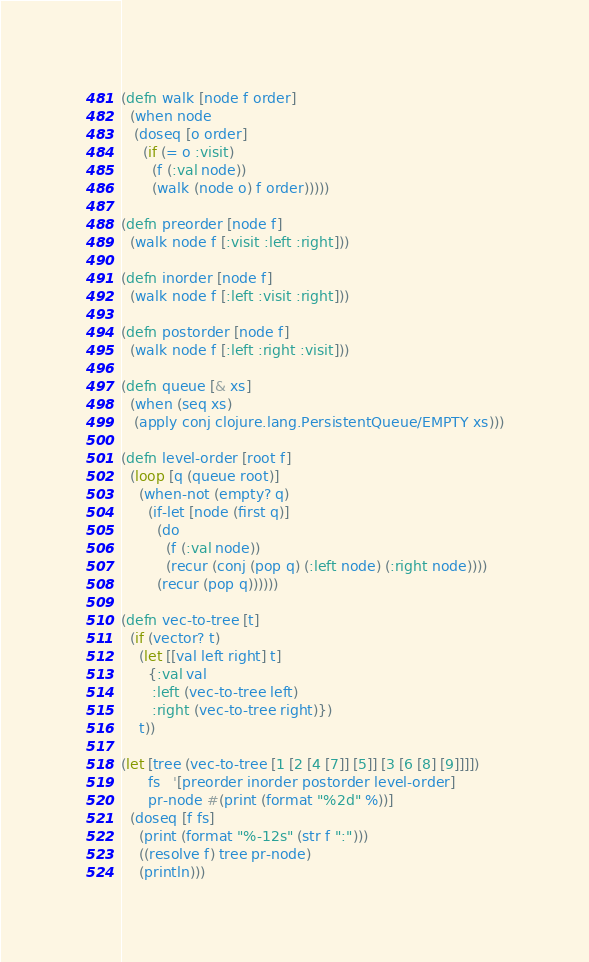Convert code to text. <code><loc_0><loc_0><loc_500><loc_500><_Clojure_>(defn walk [node f order]
  (when node
   (doseq [o order]
     (if (= o :visit)
       (f (:val node))
       (walk (node o) f order)))))

(defn preorder [node f]
  (walk node f [:visit :left :right]))

(defn inorder [node f]
  (walk node f [:left :visit :right]))

(defn postorder [node f]
  (walk node f [:left :right :visit]))

(defn queue [& xs]
  (when (seq xs)
   (apply conj clojure.lang.PersistentQueue/EMPTY xs)))

(defn level-order [root f]
  (loop [q (queue root)]
    (when-not (empty? q)
      (if-let [node (first q)]
        (do
          (f (:val node))
          (recur (conj (pop q) (:left node) (:right node))))
        (recur (pop q))))))

(defn vec-to-tree [t]
  (if (vector? t)
    (let [[val left right] t]
      {:val val
       :left (vec-to-tree left)
       :right (vec-to-tree right)})
    t))

(let [tree (vec-to-tree [1 [2 [4 [7]] [5]] [3 [6 [8] [9]]]])
      fs   '[preorder inorder postorder level-order]
      pr-node #(print (format "%2d" %))]
  (doseq [f fs]
    (print (format "%-12s" (str f ":")))
    ((resolve f) tree pr-node)
    (println)))
</code> 